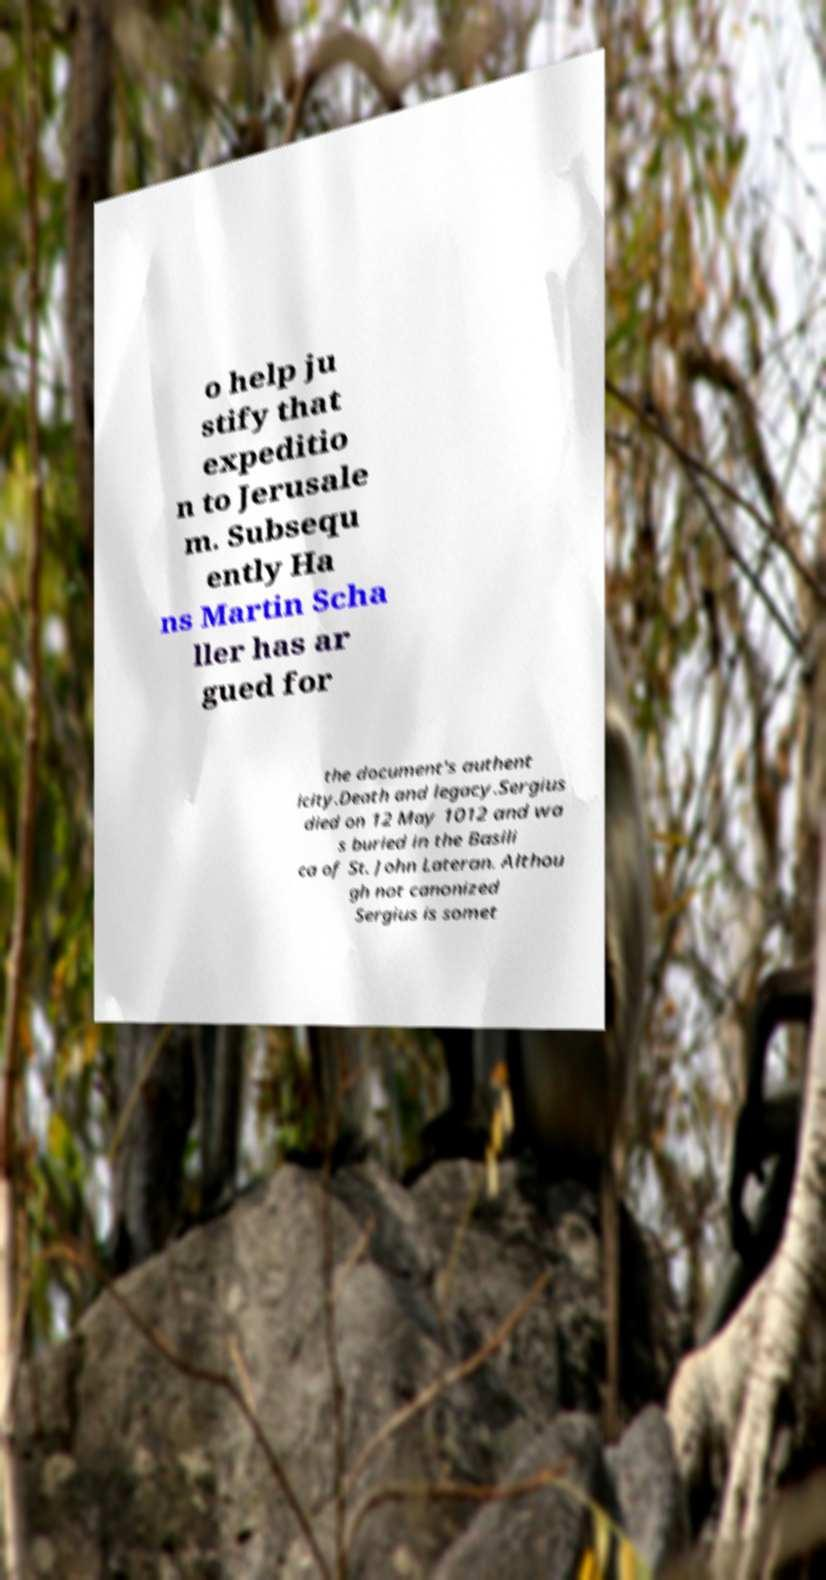Please identify and transcribe the text found in this image. o help ju stify that expeditio n to Jerusale m. Subsequ ently Ha ns Martin Scha ller has ar gued for the document's authent icity.Death and legacy.Sergius died on 12 May 1012 and wa s buried in the Basili ca of St. John Lateran. Althou gh not canonized Sergius is somet 